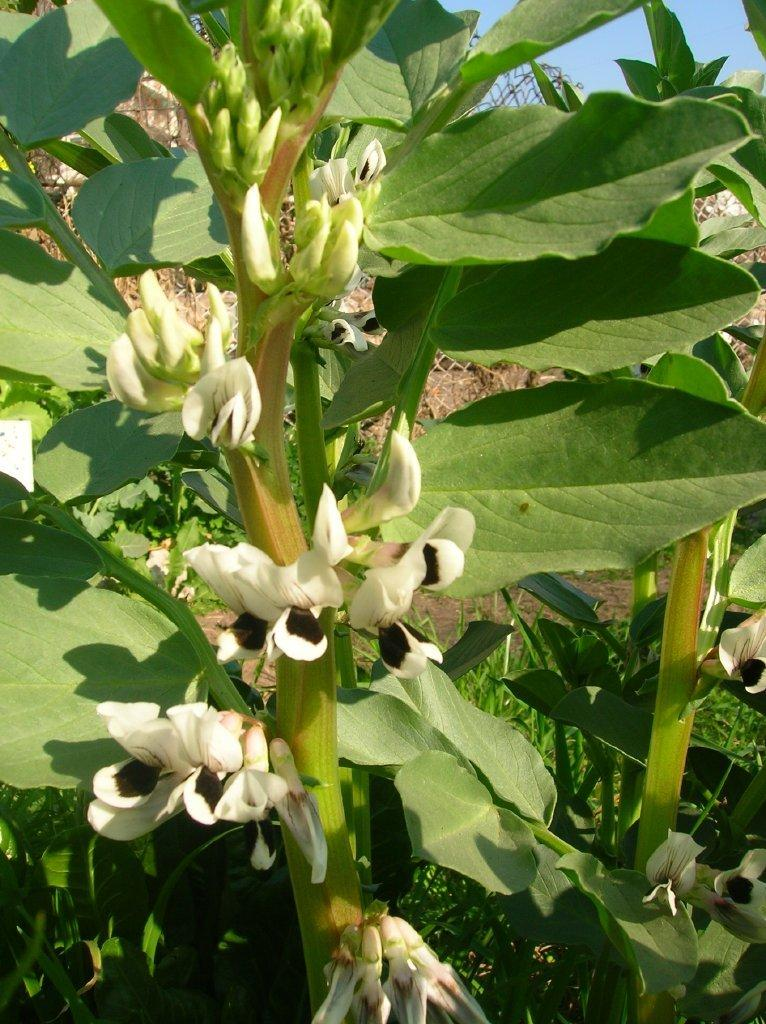What type of plants are in the image? There are plants with flowers in the image. Where are the majority of the green leaves located in the image? The majority of the green leaves are on the left side of the image. What can be seen in the top right corner of the image? There is water visible in the top right corner of the image. What type of note is attached to the face in the image? There is no face or note present in the image. 